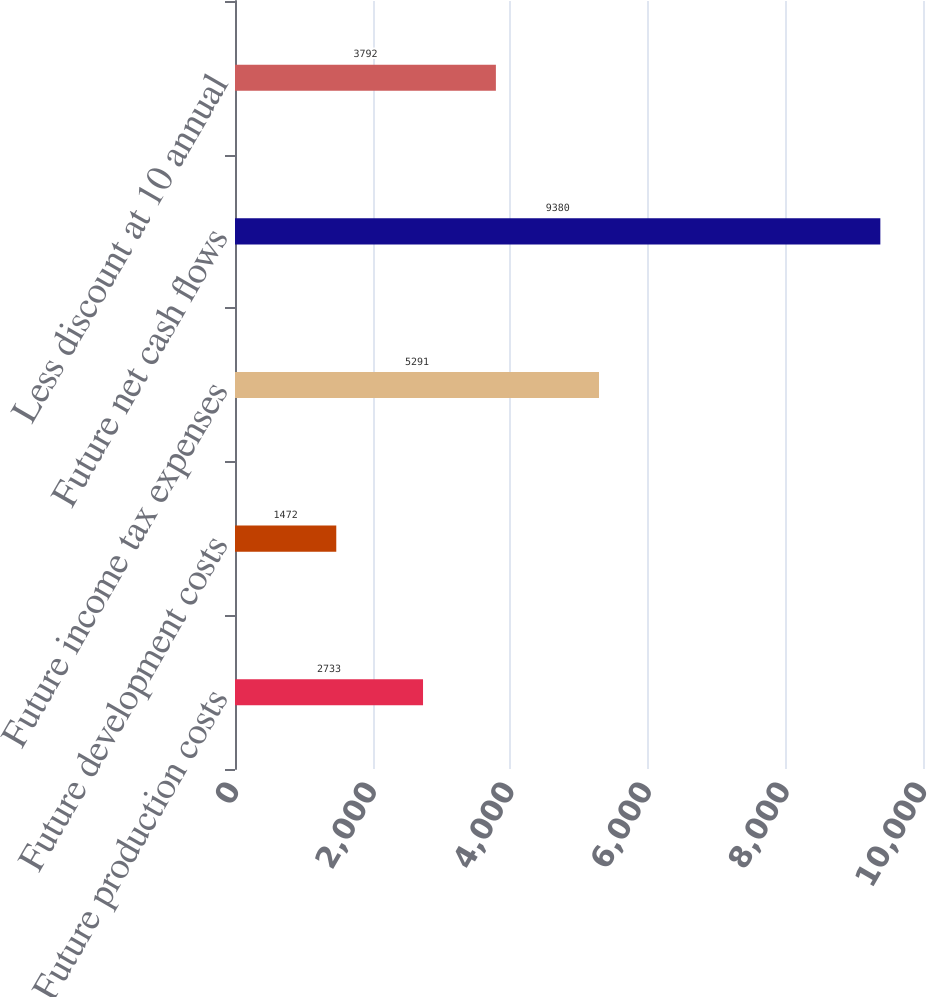<chart> <loc_0><loc_0><loc_500><loc_500><bar_chart><fcel>Future production costs<fcel>Future development costs<fcel>Future income tax expenses<fcel>Future net cash flows<fcel>Less discount at 10 annual<nl><fcel>2733<fcel>1472<fcel>5291<fcel>9380<fcel>3792<nl></chart> 